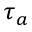Convert formula to latex. <formula><loc_0><loc_0><loc_500><loc_500>\tau _ { a }</formula> 